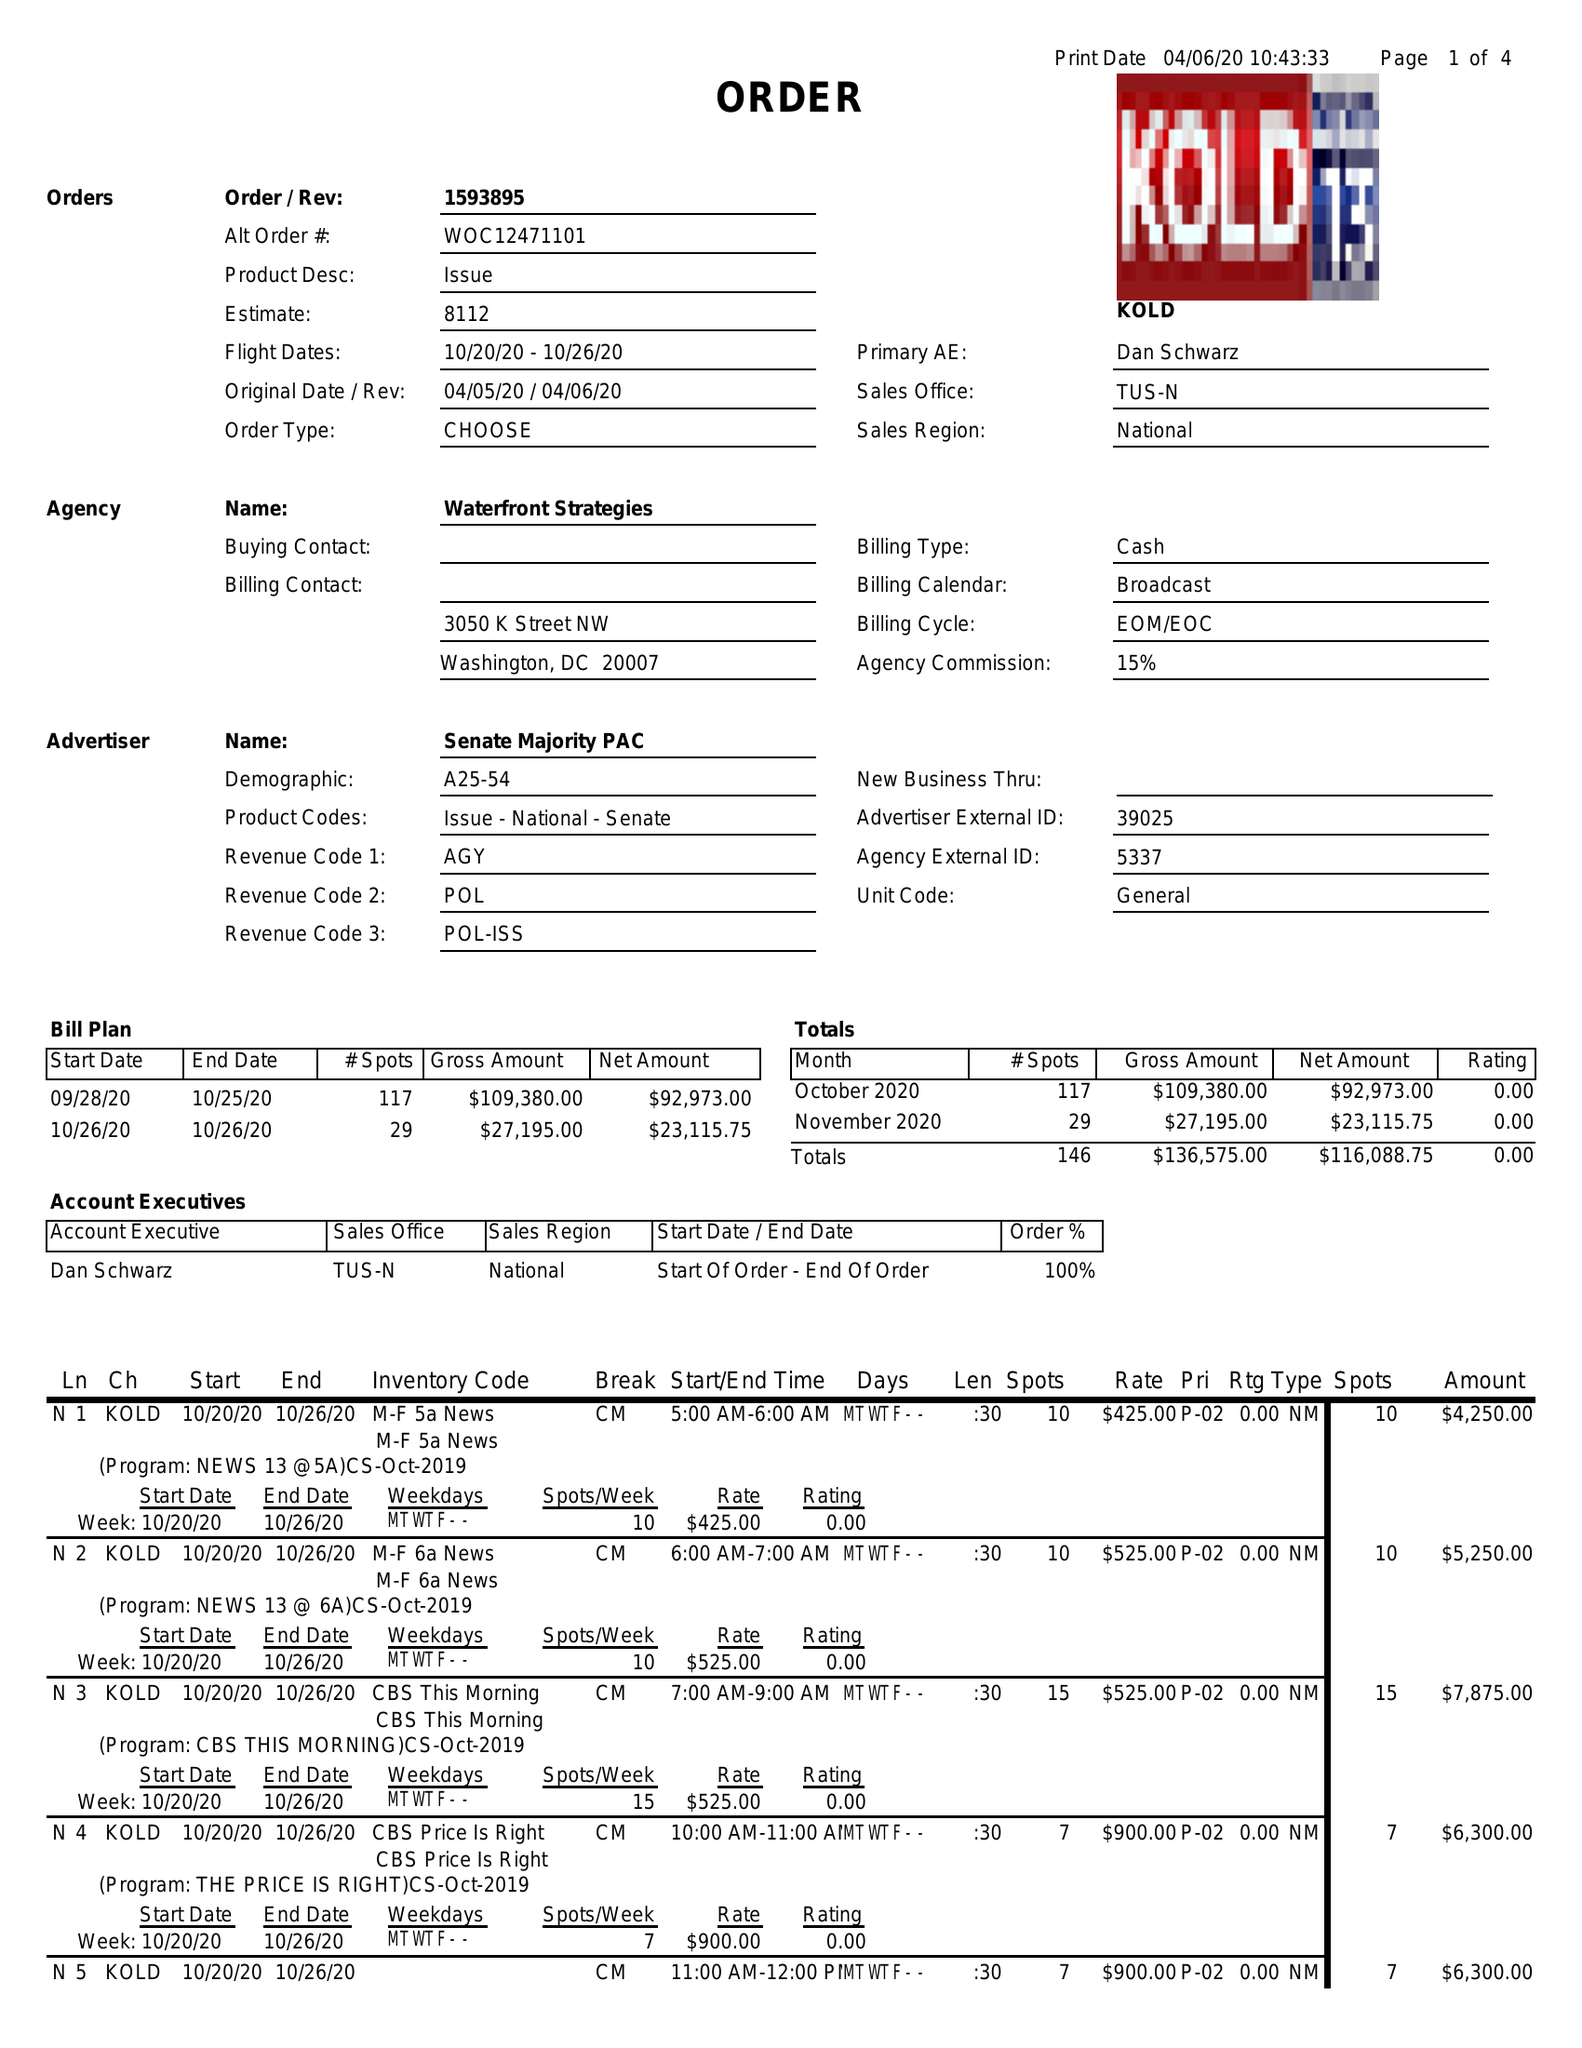What is the value for the advertiser?
Answer the question using a single word or phrase. SENATE MAJORITY PAC 